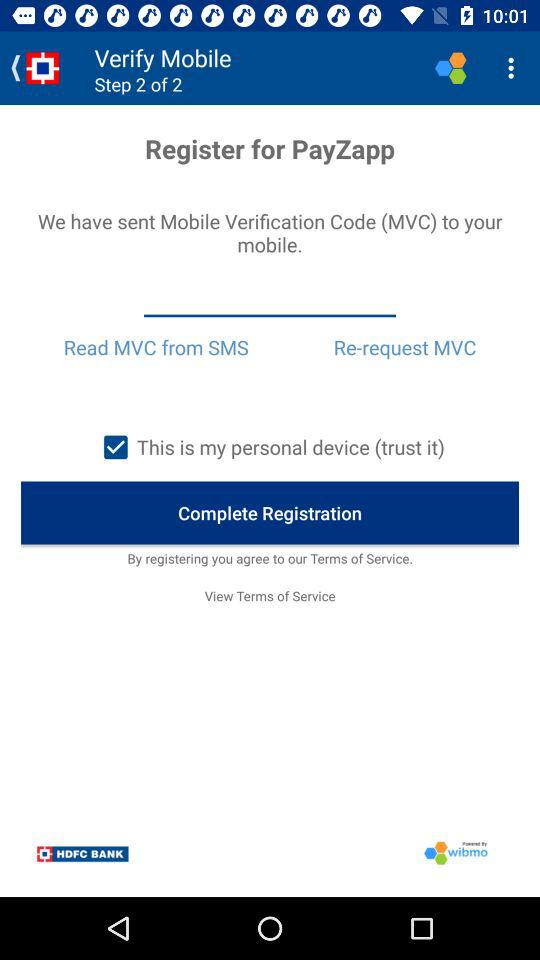How many verification steps in total are there? There are 2 verification steps in total. 